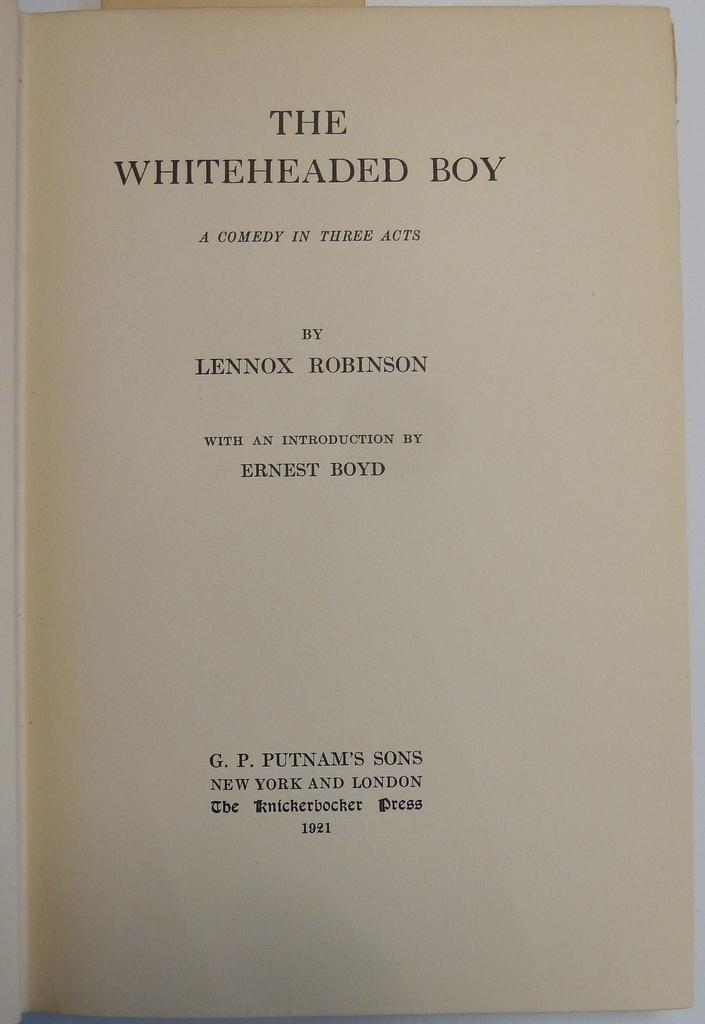<image>
Give a short and clear explanation of the subsequent image. A page titled "The whiteheaded boy" which is a comedy that has three acts. 